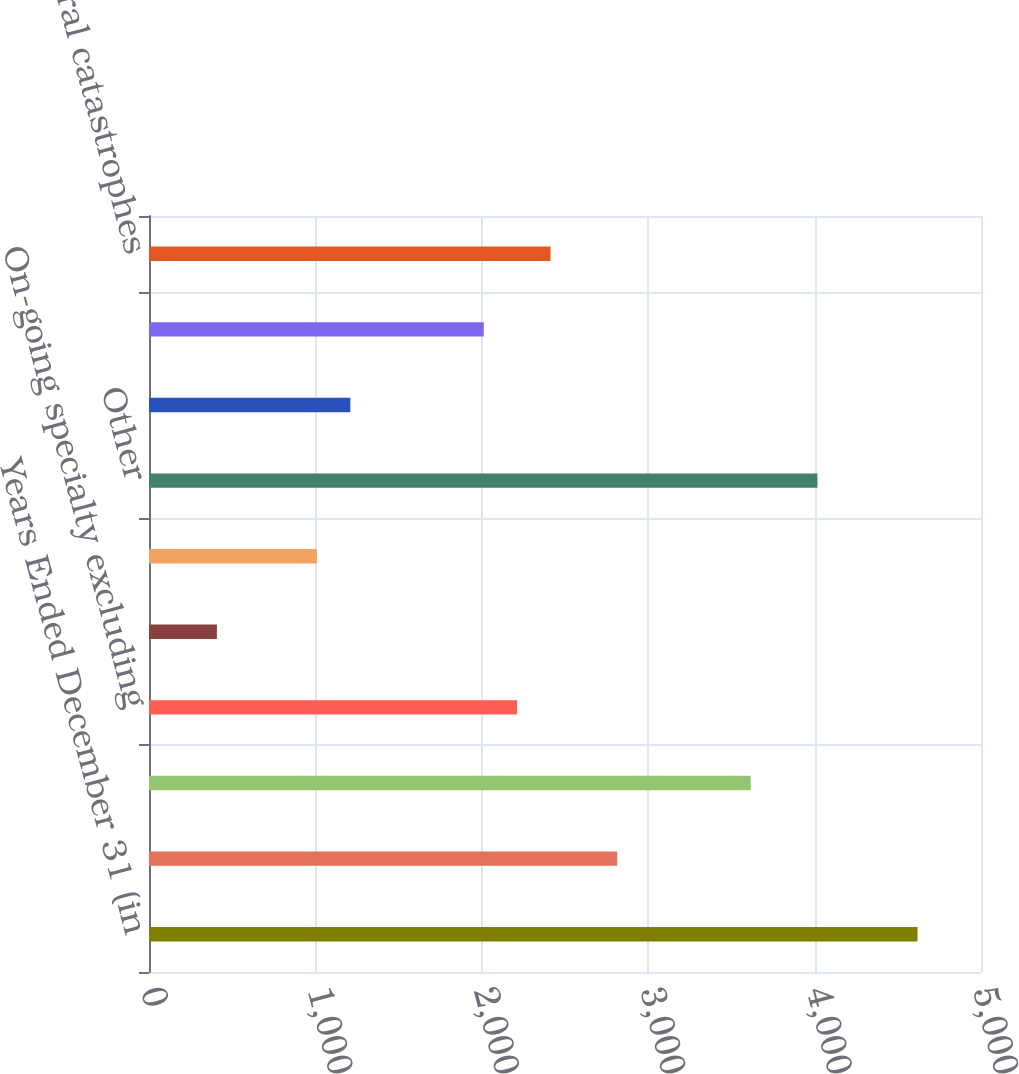Convert chart. <chart><loc_0><loc_0><loc_500><loc_500><bar_chart><fcel>Years Ended December 31 (in<fcel>Excess casualty<fcel>Financial lines including<fcel>On-going specialty excluding<fcel>On-going pollution products<fcel>Loss-sensitive<fcel>Other<fcel>Healthcare<fcel>Property excluding natural<fcel>Natural catastrophes<nl><fcel>4618.5<fcel>2814<fcel>3616<fcel>2212.5<fcel>408<fcel>1009.5<fcel>4017<fcel>1210<fcel>2012<fcel>2413<nl></chart> 